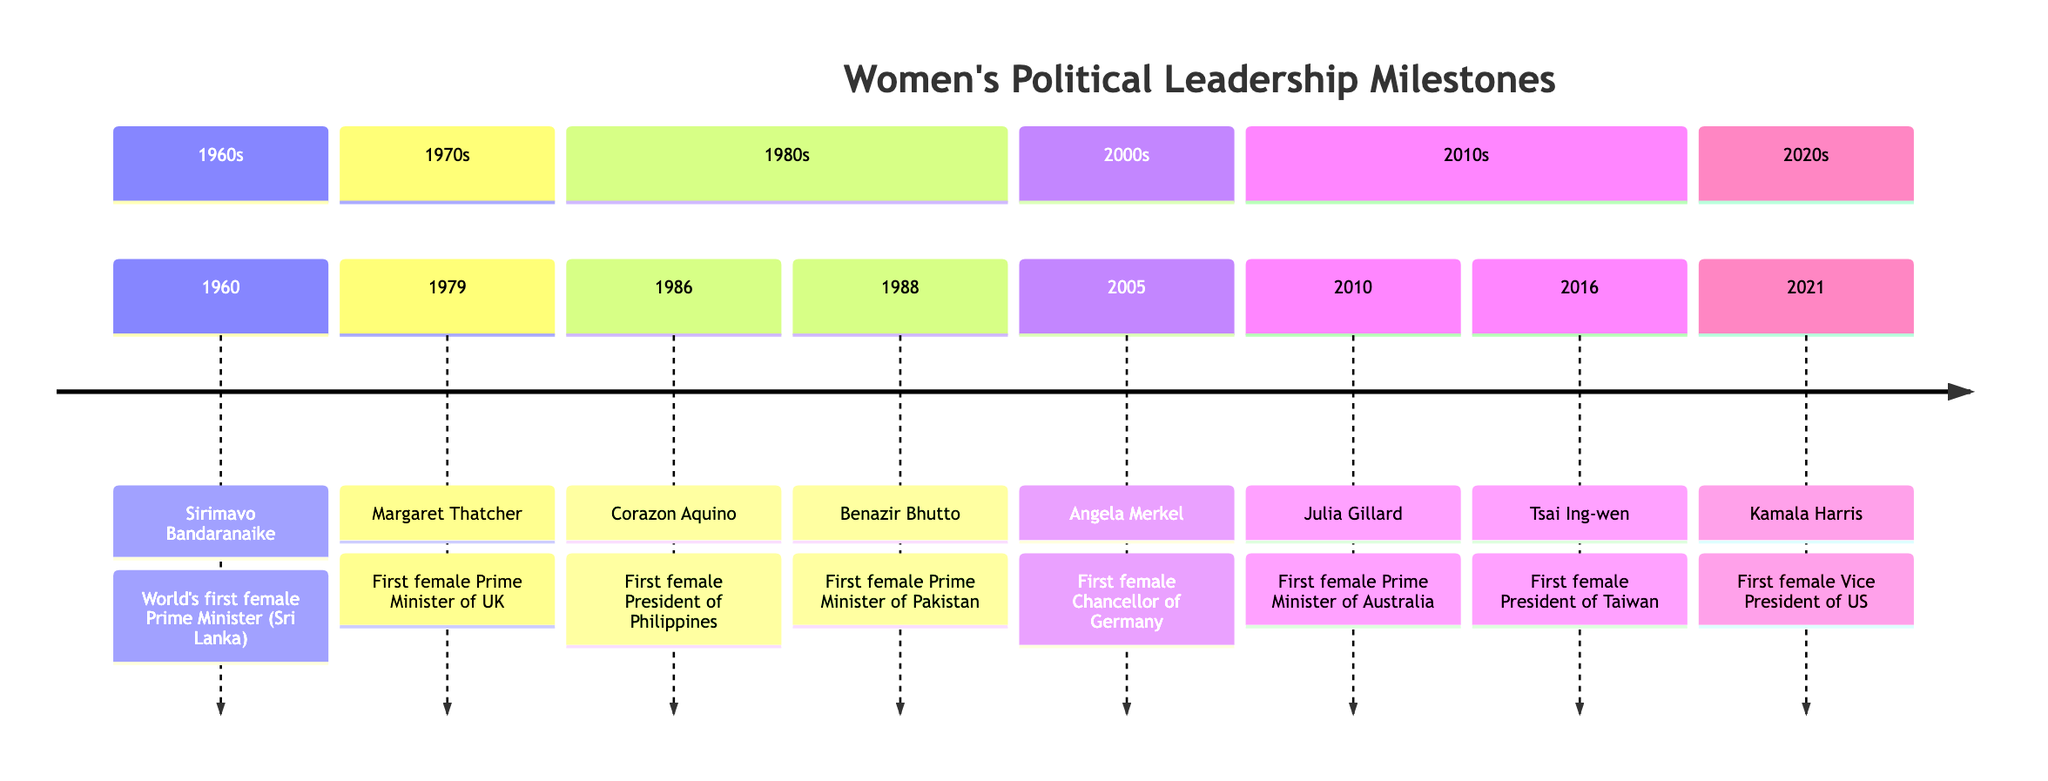What year did Sirimavo Bandaranaike become Prime Minister? According to the timeline, Sirimavo Bandaranaike was elected as the world's first female Prime Minister in 1960.
Answer: 1960 Who was the first female Prime Minister of the United Kingdom? The diagram indicates that Margaret Thatcher was elected as the first female Prime Minister of the United Kingdom in 1979.
Answer: Margaret Thatcher How many female political leaders are shown on the timeline? By counting each entry in the timeline, there are a total of 8 female political leaders represented.
Answer: 8 Which leader became the first female President of the Philippines? The timeline states that Corazon Aquino was elected as the first female President of the Philippines in 1986.
Answer: Corazon Aquino What significant political milestone occurred in 2021? Kamala Harris was inaugurated as the first female Vice President of the United States in 2021, which is highlighted in the timeline.
Answer: Kamala Harris Which two leaders had their political achievements in the 1980s? The leaders identified in the timeline under the 1980s section are Corazon Aquino (1986) and Benazir Bhutto (1988), thus both had their achievements during that decade.
Answer: Corazon Aquino and Benazir Bhutto What is the earliest year listed in the timeline? The first entry in the timeline shows the year 1960 as the earliest year when Sirimavo Bandaranaike was elected.
Answer: 1960 Which female leader was elected as the first Chancellor of Germany? According to the timeline, Angela Merkel was elected as the first female Chancellor of Germany in 2005.
Answer: Angela Merkel Who is the highest-ranking female official in U.S. history according to the timeline? The diagram states that Kamala Harris, as the first female Vice President, is recognized as the highest-ranking female official in U.S. history as of 2021.
Answer: Kamala Harris 